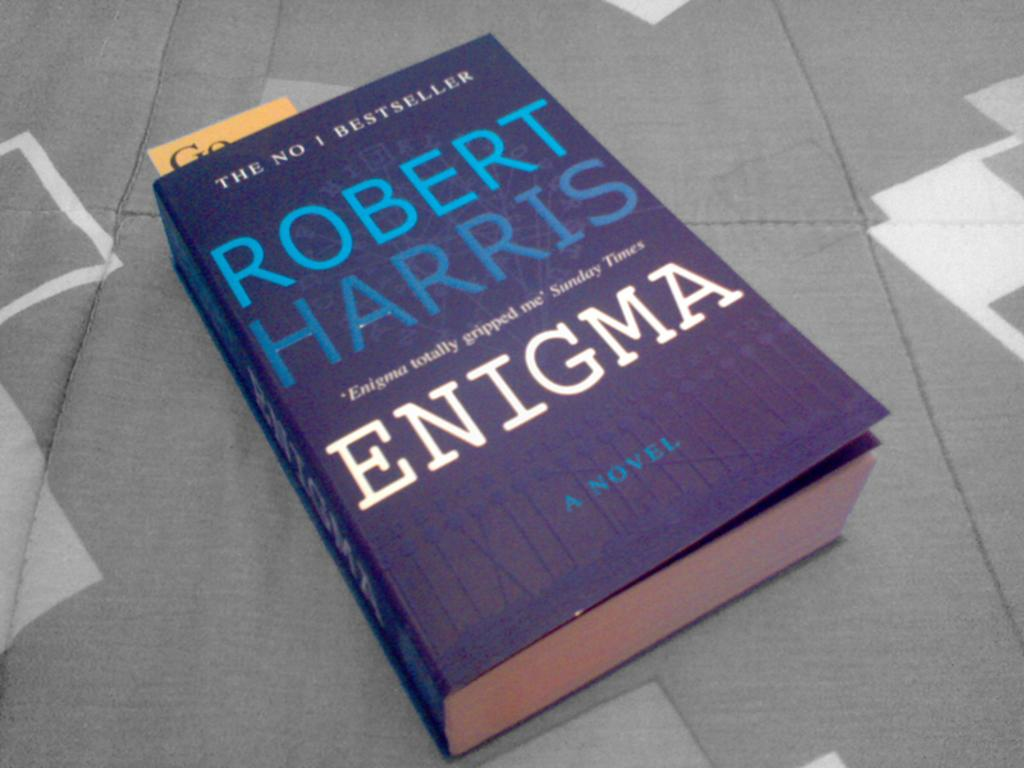<image>
Present a compact description of the photo's key features. Robert Harris's novel Enigma has a dark blue cover. 